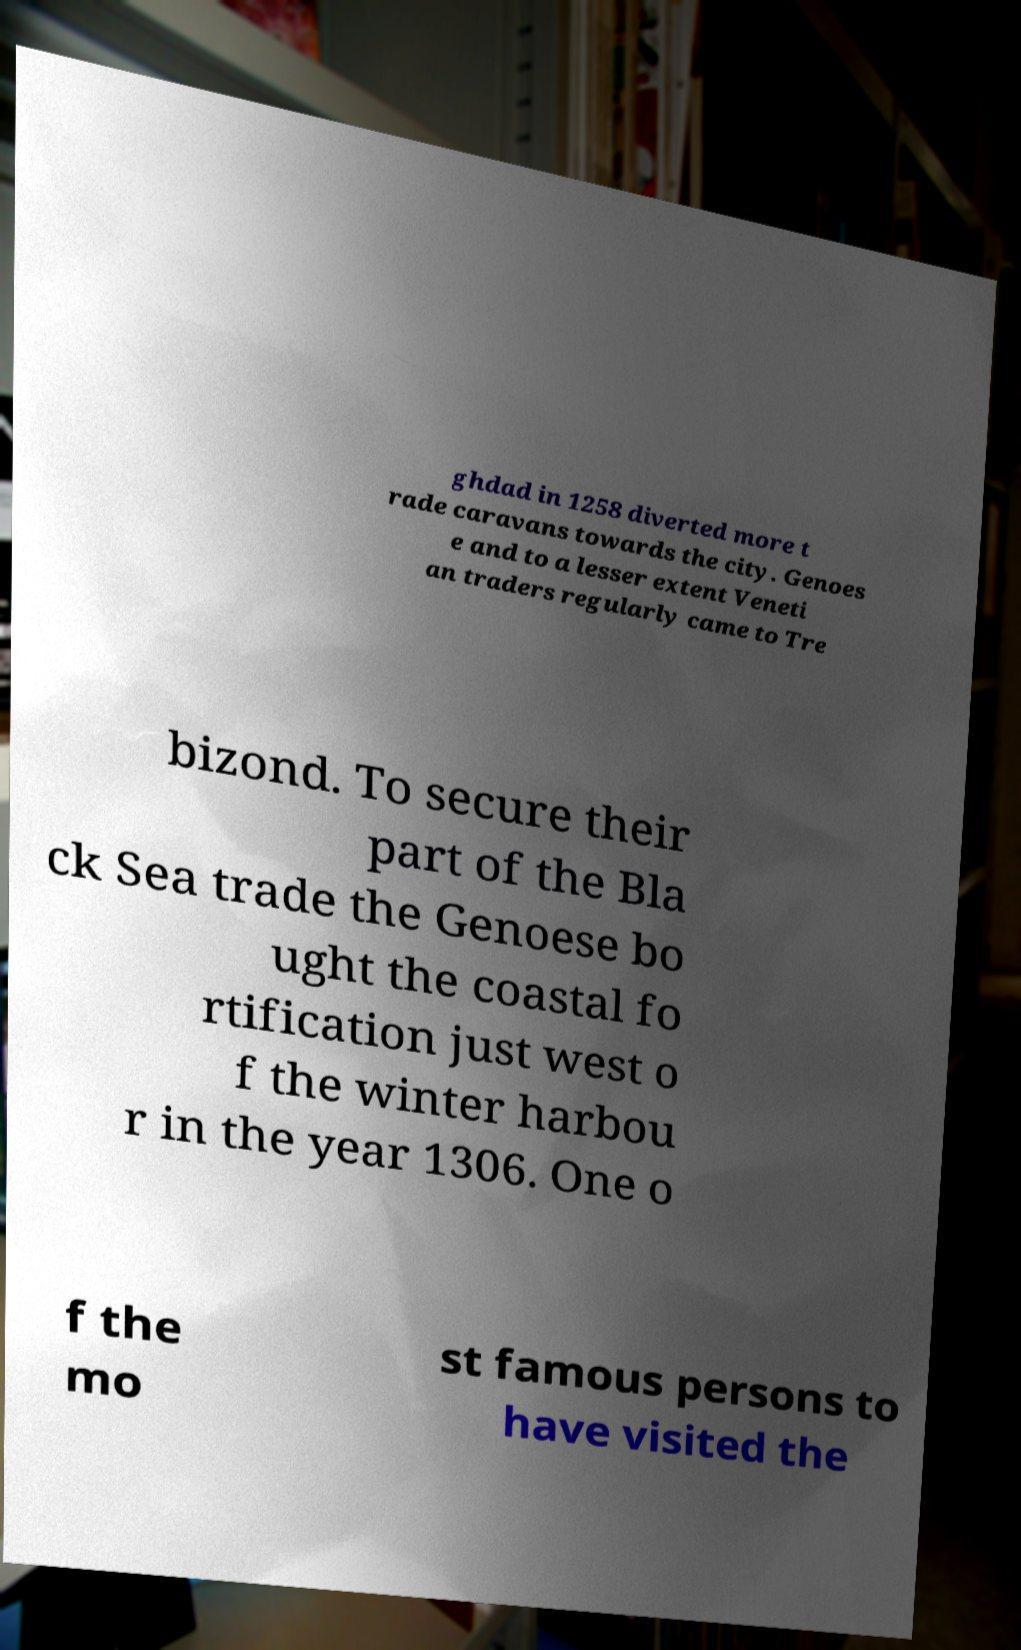Can you read and provide the text displayed in the image?This photo seems to have some interesting text. Can you extract and type it out for me? ghdad in 1258 diverted more t rade caravans towards the city. Genoes e and to a lesser extent Veneti an traders regularly came to Tre bizond. To secure their part of the Bla ck Sea trade the Genoese bo ught the coastal fo rtification just west o f the winter harbou r in the year 1306. One o f the mo st famous persons to have visited the 